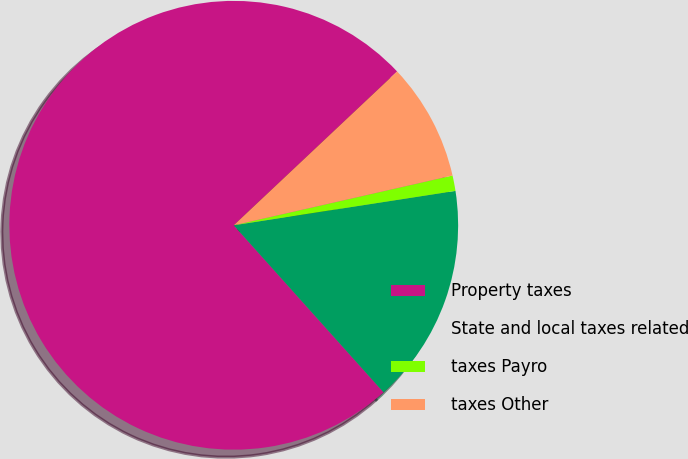Convert chart. <chart><loc_0><loc_0><loc_500><loc_500><pie_chart><fcel>Property taxes<fcel>State and local taxes related<fcel>taxes Payro<fcel>taxes Other<nl><fcel>74.61%<fcel>15.81%<fcel>1.11%<fcel>8.46%<nl></chart> 